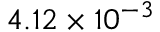Convert formula to latex. <formula><loc_0><loc_0><loc_500><loc_500>4 . 1 2 \times 1 0 ^ { - 3 }</formula> 